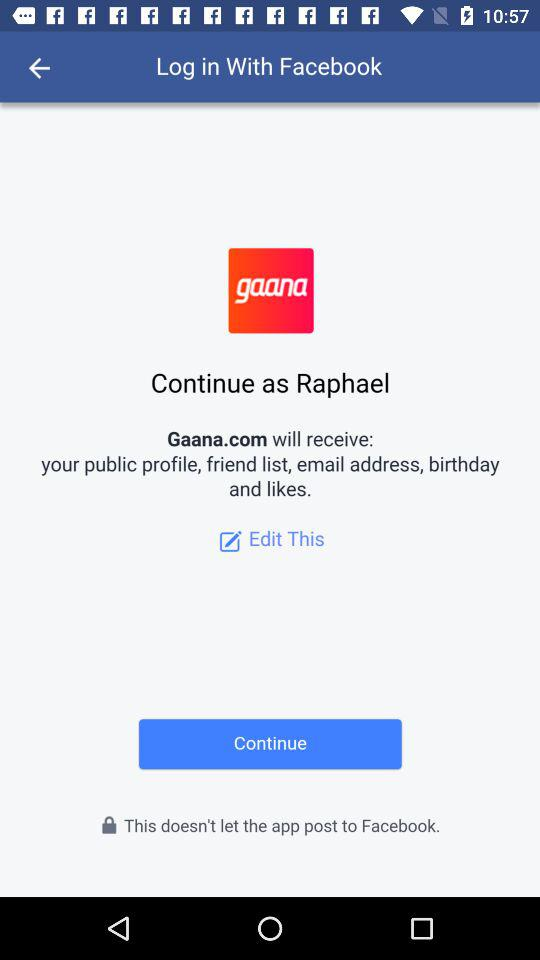What is the user name? The user name is Raphael. 